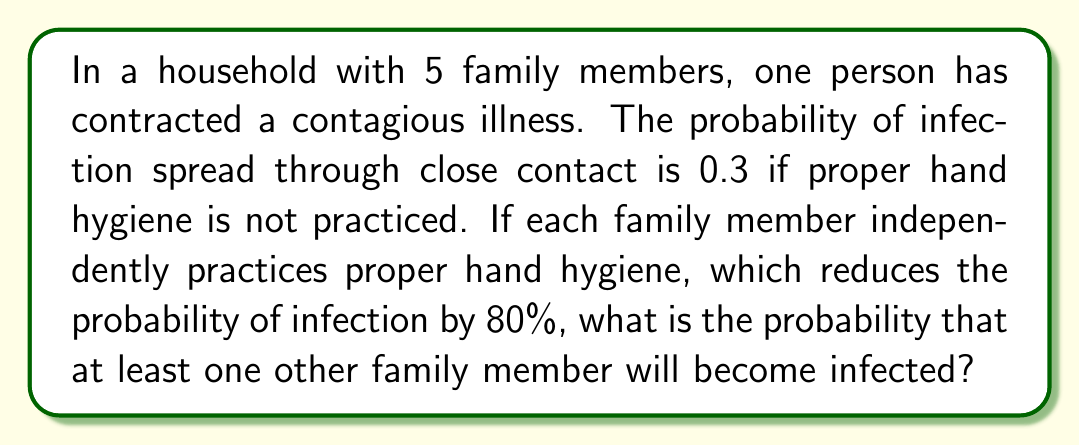Provide a solution to this math problem. Let's approach this step-by-step:

1) First, let's calculate the probability of infection with proper hand hygiene:
   $P(\text{infection with hygiene}) = 0.3 \times (1 - 0.8) = 0.3 \times 0.2 = 0.06$

2) Now, we need to find the probability that at least one other family member becomes infected. It's easier to calculate the probability that no one becomes infected and then subtract from 1.

3) For each family member, the probability of not becoming infected is:
   $P(\text{not infected}) = 1 - 0.06 = 0.94$

4) Since there are 4 other family members (excluding the initially infected person), and assuming independence, the probability that none of them become infected is:
   $P(\text{no one infected}) = 0.94^4$

5) Therefore, the probability that at least one person becomes infected is:
   $$P(\text{at least one infected}) = 1 - P(\text{no one infected}) = 1 - 0.94^4$$

6) Let's calculate this:
   $$1 - 0.94^4 = 1 - 0.7799 = 0.2201$$

7) Converting to a percentage:
   $0.2201 \times 100\% = 22.01\%$
Answer: The probability that at least one other family member will become infected is approximately 22.01%. 